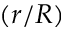<formula> <loc_0><loc_0><loc_500><loc_500>( r / R )</formula> 